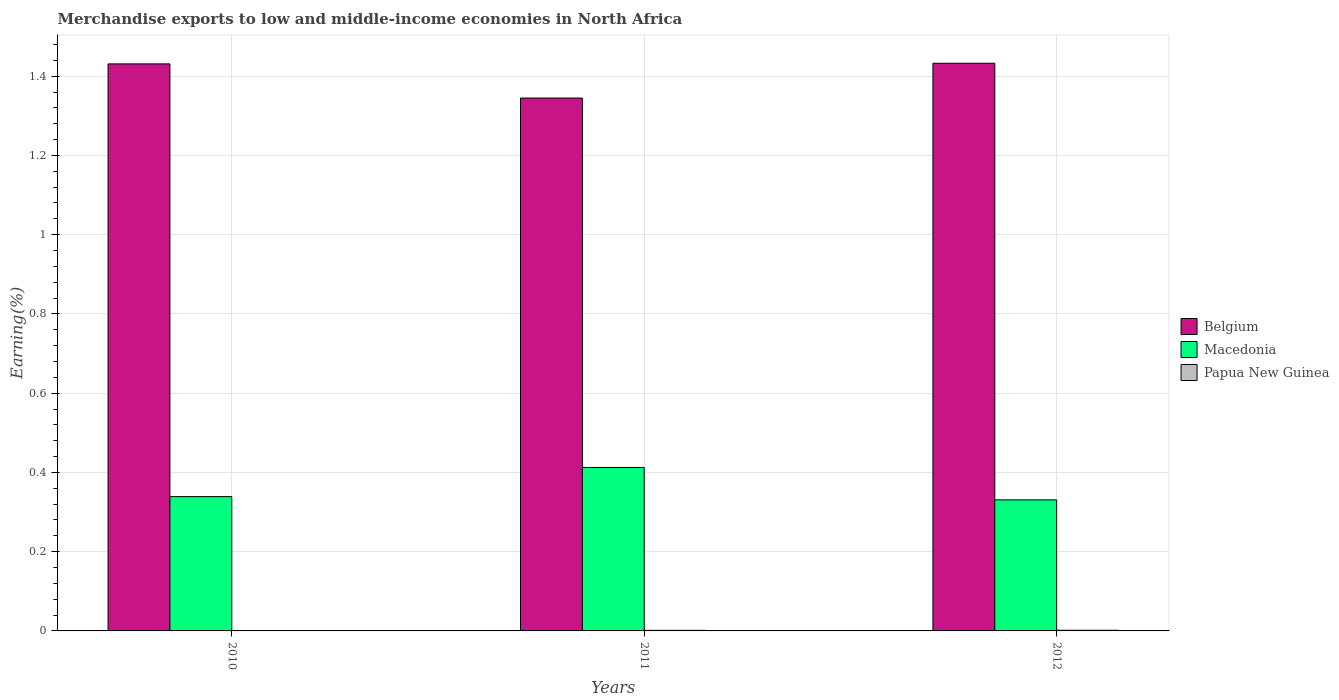Are the number of bars per tick equal to the number of legend labels?
Offer a terse response. Yes. What is the label of the 2nd group of bars from the left?
Offer a terse response. 2011. What is the percentage of amount earned from merchandise exports in Papua New Guinea in 2011?
Your answer should be very brief. 0. Across all years, what is the maximum percentage of amount earned from merchandise exports in Macedonia?
Provide a succinct answer. 0.41. Across all years, what is the minimum percentage of amount earned from merchandise exports in Belgium?
Your response must be concise. 1.34. In which year was the percentage of amount earned from merchandise exports in Macedonia maximum?
Provide a succinct answer. 2011. In which year was the percentage of amount earned from merchandise exports in Macedonia minimum?
Make the answer very short. 2012. What is the total percentage of amount earned from merchandise exports in Papua New Guinea in the graph?
Your answer should be compact. 0. What is the difference between the percentage of amount earned from merchandise exports in Macedonia in 2010 and that in 2011?
Offer a terse response. -0.07. What is the difference between the percentage of amount earned from merchandise exports in Macedonia in 2011 and the percentage of amount earned from merchandise exports in Belgium in 2010?
Your response must be concise. -1.02. What is the average percentage of amount earned from merchandise exports in Papua New Guinea per year?
Ensure brevity in your answer.  0. In the year 2011, what is the difference between the percentage of amount earned from merchandise exports in Macedonia and percentage of amount earned from merchandise exports in Papua New Guinea?
Your response must be concise. 0.41. What is the ratio of the percentage of amount earned from merchandise exports in Belgium in 2010 to that in 2012?
Give a very brief answer. 1. Is the percentage of amount earned from merchandise exports in Papua New Guinea in 2010 less than that in 2012?
Provide a short and direct response. Yes. Is the difference between the percentage of amount earned from merchandise exports in Macedonia in 2010 and 2011 greater than the difference between the percentage of amount earned from merchandise exports in Papua New Guinea in 2010 and 2011?
Ensure brevity in your answer.  No. What is the difference between the highest and the second highest percentage of amount earned from merchandise exports in Macedonia?
Offer a very short reply. 0.07. What is the difference between the highest and the lowest percentage of amount earned from merchandise exports in Belgium?
Your response must be concise. 0.09. In how many years, is the percentage of amount earned from merchandise exports in Macedonia greater than the average percentage of amount earned from merchandise exports in Macedonia taken over all years?
Make the answer very short. 1. What does the 3rd bar from the left in 2011 represents?
Give a very brief answer. Papua New Guinea. What does the 2nd bar from the right in 2010 represents?
Give a very brief answer. Macedonia. Is it the case that in every year, the sum of the percentage of amount earned from merchandise exports in Belgium and percentage of amount earned from merchandise exports in Papua New Guinea is greater than the percentage of amount earned from merchandise exports in Macedonia?
Provide a succinct answer. Yes. How many bars are there?
Provide a succinct answer. 9. How many years are there in the graph?
Provide a short and direct response. 3. Where does the legend appear in the graph?
Your answer should be compact. Center right. How many legend labels are there?
Your answer should be compact. 3. How are the legend labels stacked?
Keep it short and to the point. Vertical. What is the title of the graph?
Offer a terse response. Merchandise exports to low and middle-income economies in North Africa. Does "Monaco" appear as one of the legend labels in the graph?
Ensure brevity in your answer.  No. What is the label or title of the X-axis?
Provide a short and direct response. Years. What is the label or title of the Y-axis?
Make the answer very short. Earning(%). What is the Earning(%) in Belgium in 2010?
Keep it short and to the point. 1.43. What is the Earning(%) in Macedonia in 2010?
Your answer should be very brief. 0.34. What is the Earning(%) in Papua New Guinea in 2010?
Your answer should be compact. 3.96869620498379e-5. What is the Earning(%) in Belgium in 2011?
Offer a terse response. 1.34. What is the Earning(%) in Macedonia in 2011?
Keep it short and to the point. 0.41. What is the Earning(%) in Papua New Guinea in 2011?
Provide a short and direct response. 0. What is the Earning(%) in Belgium in 2012?
Provide a succinct answer. 1.43. What is the Earning(%) in Macedonia in 2012?
Ensure brevity in your answer.  0.33. What is the Earning(%) of Papua New Guinea in 2012?
Ensure brevity in your answer.  0. Across all years, what is the maximum Earning(%) of Belgium?
Make the answer very short. 1.43. Across all years, what is the maximum Earning(%) in Macedonia?
Provide a short and direct response. 0.41. Across all years, what is the maximum Earning(%) in Papua New Guinea?
Your response must be concise. 0. Across all years, what is the minimum Earning(%) of Belgium?
Your answer should be compact. 1.34. Across all years, what is the minimum Earning(%) of Macedonia?
Provide a succinct answer. 0.33. Across all years, what is the minimum Earning(%) in Papua New Guinea?
Keep it short and to the point. 3.96869620498379e-5. What is the total Earning(%) of Belgium in the graph?
Provide a short and direct response. 4.21. What is the total Earning(%) of Macedonia in the graph?
Provide a succinct answer. 1.08. What is the total Earning(%) in Papua New Guinea in the graph?
Keep it short and to the point. 0. What is the difference between the Earning(%) in Belgium in 2010 and that in 2011?
Give a very brief answer. 0.09. What is the difference between the Earning(%) in Macedonia in 2010 and that in 2011?
Give a very brief answer. -0.07. What is the difference between the Earning(%) of Papua New Guinea in 2010 and that in 2011?
Give a very brief answer. -0. What is the difference between the Earning(%) of Belgium in 2010 and that in 2012?
Ensure brevity in your answer.  -0. What is the difference between the Earning(%) of Macedonia in 2010 and that in 2012?
Provide a short and direct response. 0.01. What is the difference between the Earning(%) in Papua New Guinea in 2010 and that in 2012?
Your answer should be compact. -0. What is the difference between the Earning(%) in Belgium in 2011 and that in 2012?
Offer a very short reply. -0.09. What is the difference between the Earning(%) of Macedonia in 2011 and that in 2012?
Offer a terse response. 0.08. What is the difference between the Earning(%) in Papua New Guinea in 2011 and that in 2012?
Offer a terse response. -0. What is the difference between the Earning(%) of Belgium in 2010 and the Earning(%) of Macedonia in 2011?
Your response must be concise. 1.02. What is the difference between the Earning(%) of Belgium in 2010 and the Earning(%) of Papua New Guinea in 2011?
Ensure brevity in your answer.  1.43. What is the difference between the Earning(%) of Macedonia in 2010 and the Earning(%) of Papua New Guinea in 2011?
Offer a terse response. 0.34. What is the difference between the Earning(%) in Belgium in 2010 and the Earning(%) in Macedonia in 2012?
Your answer should be compact. 1.1. What is the difference between the Earning(%) in Belgium in 2010 and the Earning(%) in Papua New Guinea in 2012?
Your answer should be very brief. 1.43. What is the difference between the Earning(%) in Macedonia in 2010 and the Earning(%) in Papua New Guinea in 2012?
Your response must be concise. 0.34. What is the difference between the Earning(%) of Belgium in 2011 and the Earning(%) of Papua New Guinea in 2012?
Provide a short and direct response. 1.34. What is the difference between the Earning(%) of Macedonia in 2011 and the Earning(%) of Papua New Guinea in 2012?
Give a very brief answer. 0.41. What is the average Earning(%) in Belgium per year?
Offer a terse response. 1.4. What is the average Earning(%) of Macedonia per year?
Ensure brevity in your answer.  0.36. What is the average Earning(%) of Papua New Guinea per year?
Provide a succinct answer. 0. In the year 2010, what is the difference between the Earning(%) of Belgium and Earning(%) of Macedonia?
Your answer should be very brief. 1.09. In the year 2010, what is the difference between the Earning(%) of Belgium and Earning(%) of Papua New Guinea?
Your answer should be compact. 1.43. In the year 2010, what is the difference between the Earning(%) of Macedonia and Earning(%) of Papua New Guinea?
Provide a short and direct response. 0.34. In the year 2011, what is the difference between the Earning(%) of Belgium and Earning(%) of Macedonia?
Keep it short and to the point. 0.93. In the year 2011, what is the difference between the Earning(%) in Belgium and Earning(%) in Papua New Guinea?
Make the answer very short. 1.34. In the year 2011, what is the difference between the Earning(%) of Macedonia and Earning(%) of Papua New Guinea?
Keep it short and to the point. 0.41. In the year 2012, what is the difference between the Earning(%) in Belgium and Earning(%) in Macedonia?
Make the answer very short. 1.1. In the year 2012, what is the difference between the Earning(%) in Belgium and Earning(%) in Papua New Guinea?
Provide a short and direct response. 1.43. In the year 2012, what is the difference between the Earning(%) of Macedonia and Earning(%) of Papua New Guinea?
Provide a short and direct response. 0.33. What is the ratio of the Earning(%) of Belgium in 2010 to that in 2011?
Provide a succinct answer. 1.06. What is the ratio of the Earning(%) in Macedonia in 2010 to that in 2011?
Your answer should be compact. 0.82. What is the ratio of the Earning(%) of Papua New Guinea in 2010 to that in 2011?
Give a very brief answer. 0.03. What is the ratio of the Earning(%) of Macedonia in 2010 to that in 2012?
Make the answer very short. 1.02. What is the ratio of the Earning(%) in Papua New Guinea in 2010 to that in 2012?
Give a very brief answer. 0.02. What is the ratio of the Earning(%) of Belgium in 2011 to that in 2012?
Ensure brevity in your answer.  0.94. What is the ratio of the Earning(%) of Macedonia in 2011 to that in 2012?
Offer a very short reply. 1.25. What is the ratio of the Earning(%) in Papua New Guinea in 2011 to that in 2012?
Provide a short and direct response. 0.85. What is the difference between the highest and the second highest Earning(%) of Belgium?
Keep it short and to the point. 0. What is the difference between the highest and the second highest Earning(%) of Macedonia?
Your answer should be compact. 0.07. What is the difference between the highest and the second highest Earning(%) in Papua New Guinea?
Provide a short and direct response. 0. What is the difference between the highest and the lowest Earning(%) in Belgium?
Offer a very short reply. 0.09. What is the difference between the highest and the lowest Earning(%) of Macedonia?
Offer a terse response. 0.08. What is the difference between the highest and the lowest Earning(%) in Papua New Guinea?
Ensure brevity in your answer.  0. 